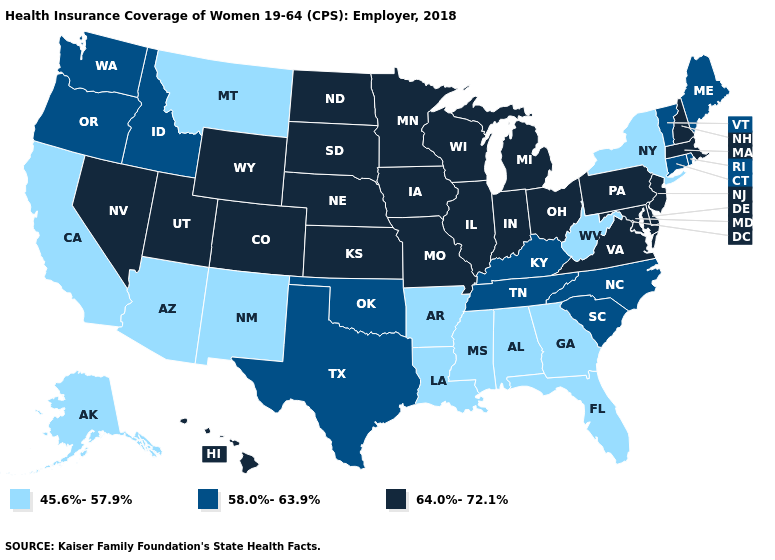What is the value of Tennessee?
Give a very brief answer. 58.0%-63.9%. What is the value of Arkansas?
Give a very brief answer. 45.6%-57.9%. Which states have the highest value in the USA?
Write a very short answer. Colorado, Delaware, Hawaii, Illinois, Indiana, Iowa, Kansas, Maryland, Massachusetts, Michigan, Minnesota, Missouri, Nebraska, Nevada, New Hampshire, New Jersey, North Dakota, Ohio, Pennsylvania, South Dakota, Utah, Virginia, Wisconsin, Wyoming. Name the states that have a value in the range 64.0%-72.1%?
Short answer required. Colorado, Delaware, Hawaii, Illinois, Indiana, Iowa, Kansas, Maryland, Massachusetts, Michigan, Minnesota, Missouri, Nebraska, Nevada, New Hampshire, New Jersey, North Dakota, Ohio, Pennsylvania, South Dakota, Utah, Virginia, Wisconsin, Wyoming. How many symbols are there in the legend?
Concise answer only. 3. Does North Dakota have a higher value than Illinois?
Be succinct. No. What is the lowest value in the USA?
Write a very short answer. 45.6%-57.9%. Among the states that border Maryland , does West Virginia have the lowest value?
Be succinct. Yes. Is the legend a continuous bar?
Concise answer only. No. Name the states that have a value in the range 64.0%-72.1%?
Short answer required. Colorado, Delaware, Hawaii, Illinois, Indiana, Iowa, Kansas, Maryland, Massachusetts, Michigan, Minnesota, Missouri, Nebraska, Nevada, New Hampshire, New Jersey, North Dakota, Ohio, Pennsylvania, South Dakota, Utah, Virginia, Wisconsin, Wyoming. Name the states that have a value in the range 45.6%-57.9%?
Short answer required. Alabama, Alaska, Arizona, Arkansas, California, Florida, Georgia, Louisiana, Mississippi, Montana, New Mexico, New York, West Virginia. What is the value of Nevada?
Quick response, please. 64.0%-72.1%. What is the highest value in the USA?
Short answer required. 64.0%-72.1%. What is the highest value in states that border Indiana?
Short answer required. 64.0%-72.1%. 